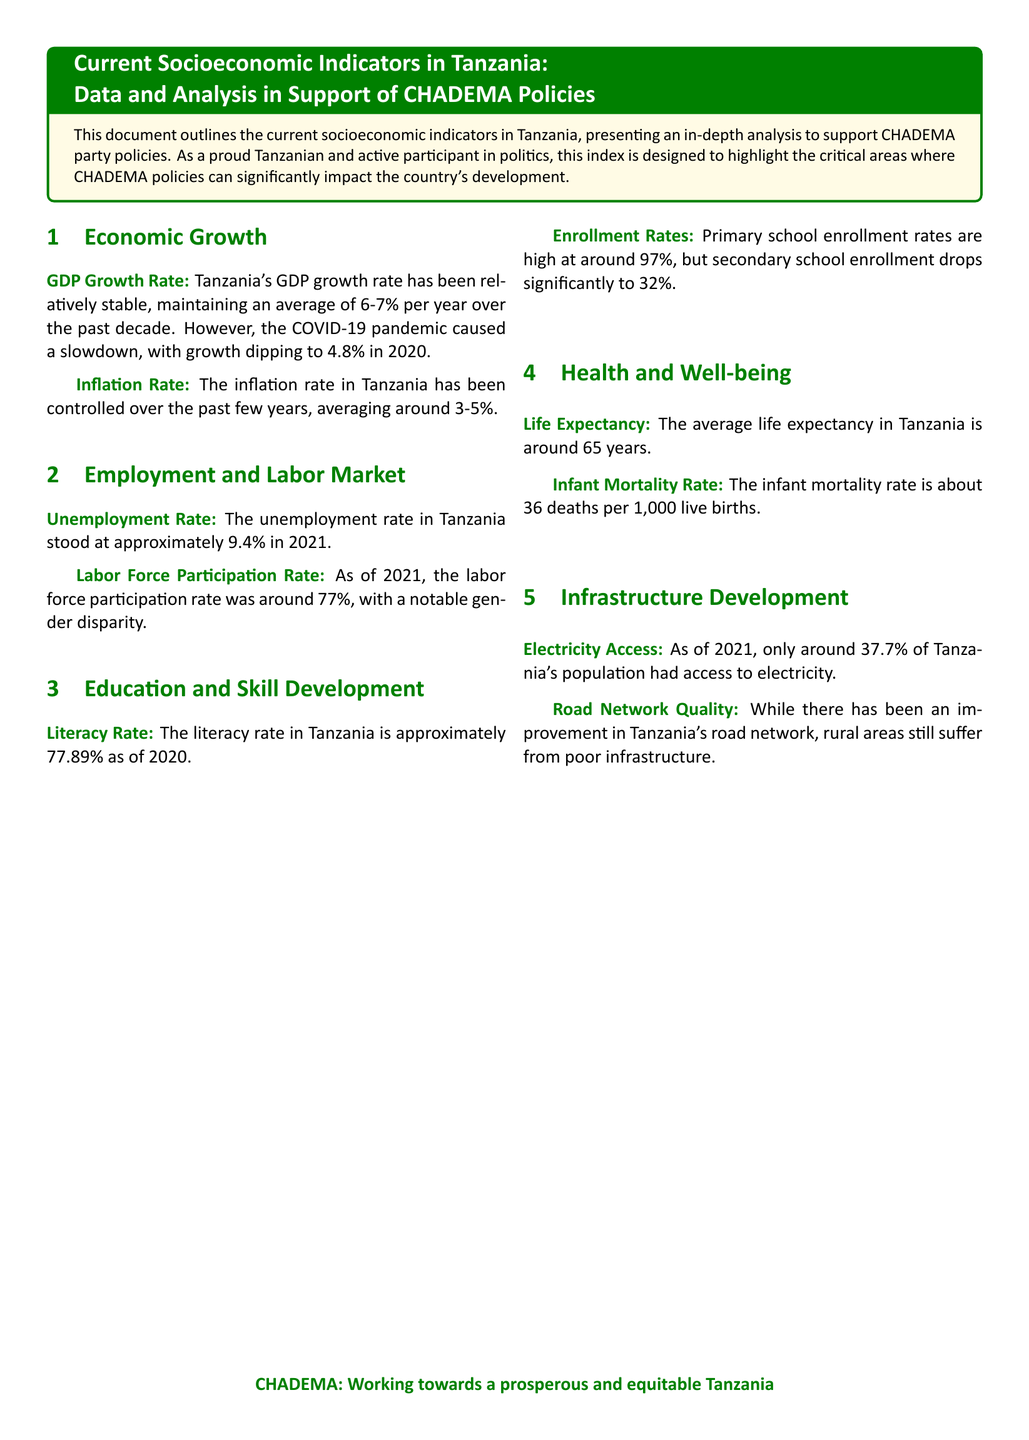What was Tanzania's GDP growth rate in 2020? The document states that due to the COVID-19 pandemic, growth dipped to 4.8% in 2020.
Answer: 4.8% What is the employment rate in Tanzania as of 2021? The unemployment rate in Tanzania stood at approximately 9.4% in 2021.
Answer: 9.4% What is the primary school enrollment rate in Tanzania? The document indicates that primary school enrollment rates are high at around 97%.
Answer: 97% What is the average life expectancy in Tanzania? According to the document, the average life expectancy in Tanzania is around 65 years.
Answer: 65 years What percentage of the population had access to electricity in 2021? The document mentions that only around 37.7% of Tanzania's population had access to electricity as of 2021.
Answer: 37.7% How does the unemployment rate and labor force participation rate compare? The document provides an unemployment rate of approximately 9.4% and a labor force participation rate of around 77%, indicating a disparity in job availability.
Answer: 9.4% and 77% Why is the secondary school enrollment rate concerning? The document highlights that secondary school enrollment drops significantly to 32%, indicating a potential area for policy improvement.
Answer: 32% What is the major health indicator mentioned in the document? The document lists the infant mortality rate as a significant health indicator, reporting about 36 deaths per 1,000 live births.
Answer: 36 deaths per 1,000 live births What color represents CHADEMA in the document? The color associated with CHADEMA is green, as indicated by the defined color "chademagreen" used throughout the document.
Answer: Green 